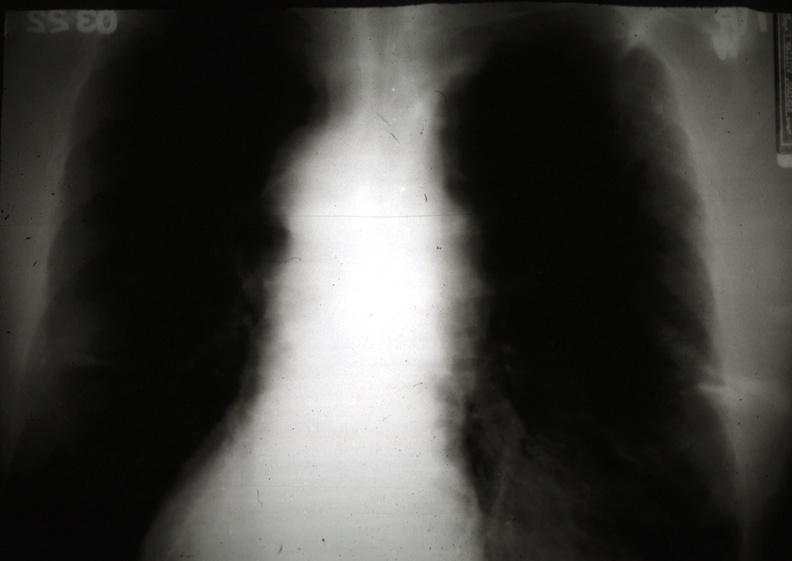s hematologic present?
Answer the question using a single word or phrase. Yes 